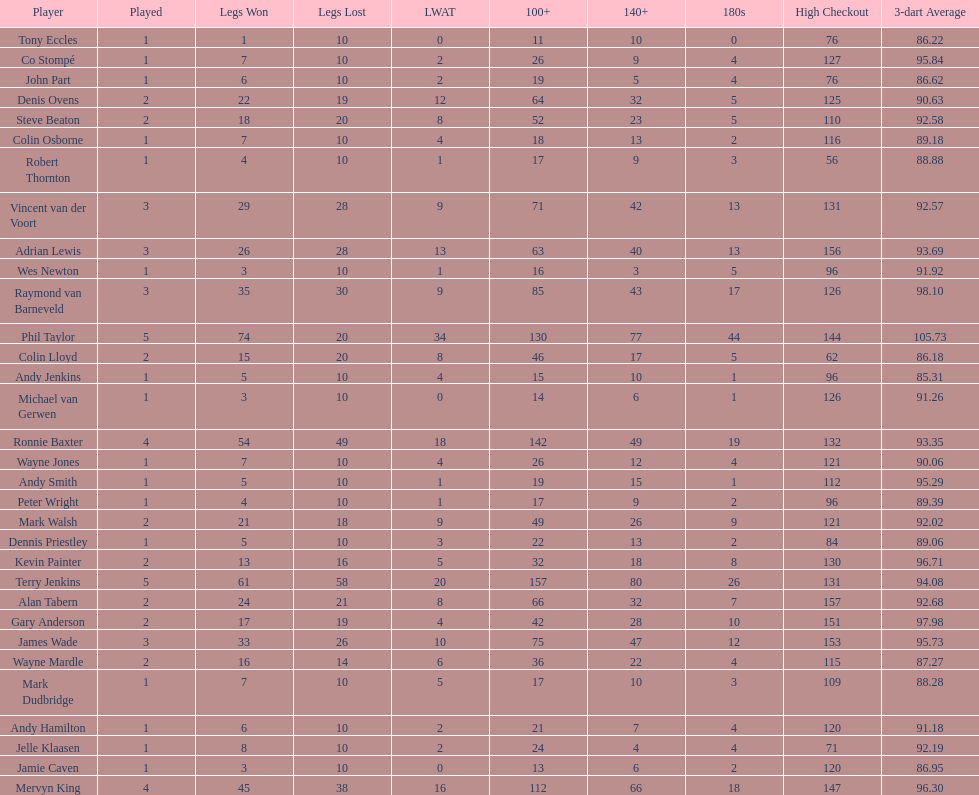Which player lost the least? Co Stompé, Andy Smith, Jelle Klaasen, Wes Newton, Michael van Gerwen, Andy Hamilton, Wayne Jones, Peter Wright, Colin Osborne, Dennis Priestley, Robert Thornton, Mark Dudbridge, Jamie Caven, John Part, Tony Eccles, Andy Jenkins. 